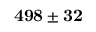<formula> <loc_0><loc_0><loc_500><loc_500>{ 4 9 8 \pm 3 2 }</formula> 